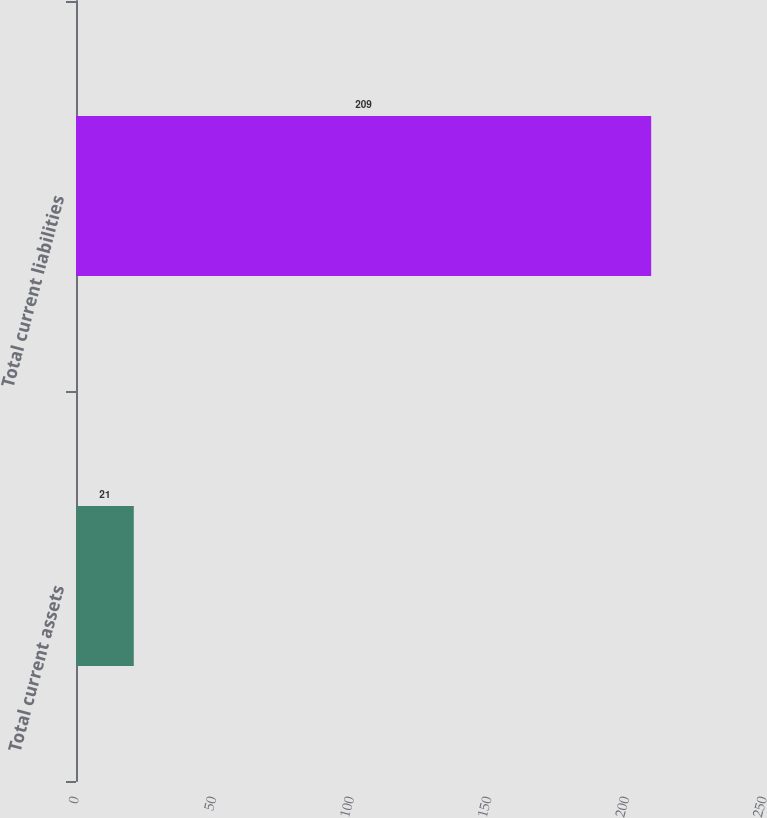Convert chart to OTSL. <chart><loc_0><loc_0><loc_500><loc_500><bar_chart><fcel>Total current assets<fcel>Total current liabilities<nl><fcel>21<fcel>209<nl></chart> 